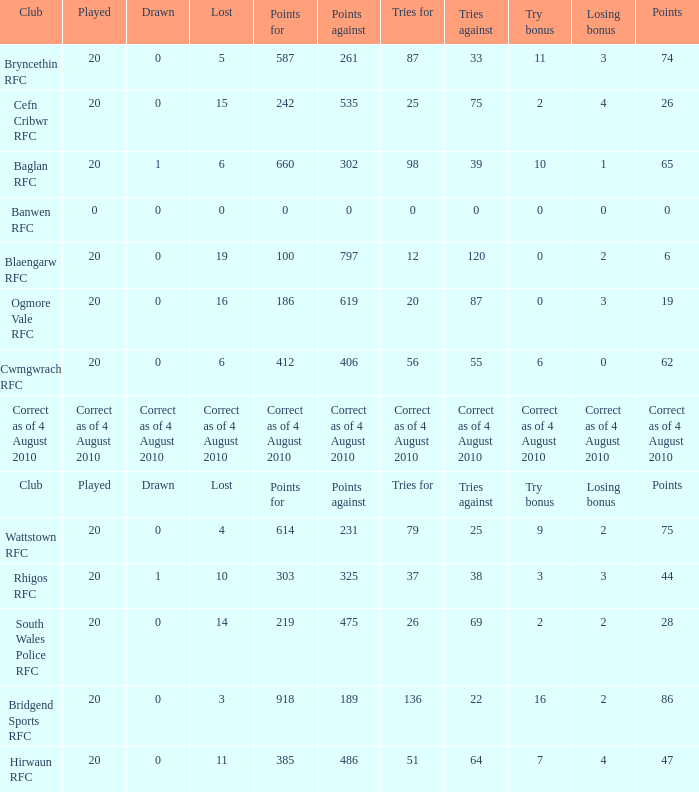What is the tries fow when losing bonus is losing bonus? Tries for. 